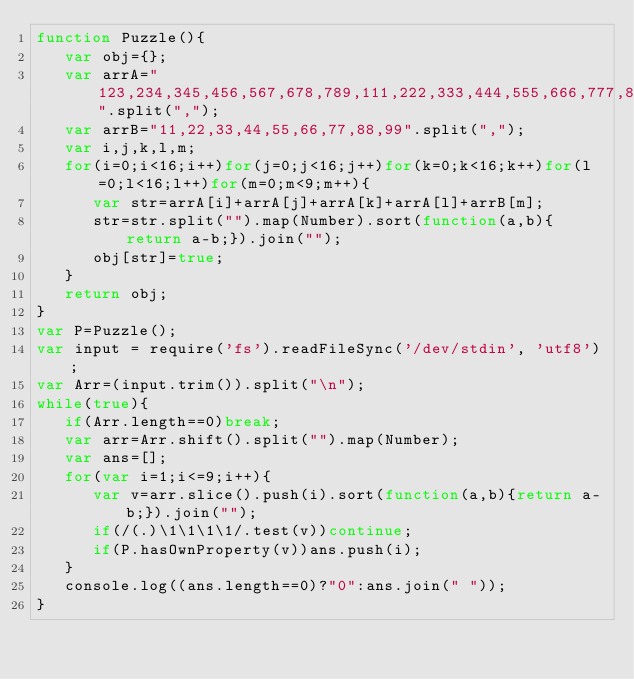Convert code to text. <code><loc_0><loc_0><loc_500><loc_500><_JavaScript_>function Puzzle(){
   var obj={};
   var arrA="123,234,345,456,567,678,789,111,222,333,444,555,666,777,888,999".split(",");
   var arrB="11,22,33,44,55,66,77,88,99".split(",");
   var i,j,k,l,m;
   for(i=0;i<16;i++)for(j=0;j<16;j++)for(k=0;k<16;k++)for(l=0;l<16;l++)for(m=0;m<9;m++){
      var str=arrA[i]+arrA[j]+arrA[k]+arrA[l]+arrB[m];
      str=str.split("").map(Number).sort(function(a,b){return a-b;}).join("");
      obj[str]=true;
   }
   return obj;
}
var P=Puzzle();
var input = require('fs').readFileSync('/dev/stdin', 'utf8');
var Arr=(input.trim()).split("\n");
while(true){
   if(Arr.length==0)break;
   var arr=Arr.shift().split("").map(Number);
   var ans=[];
   for(var i=1;i<=9;i++){
      var v=arr.slice().push(i).sort(function(a,b){return a-b;}).join("");
      if(/(.)\1\1\1\1/.test(v))continue;
      if(P.hasOwnProperty(v))ans.push(i);
   }
   console.log((ans.length==0)?"0":ans.join(" "));
}</code> 